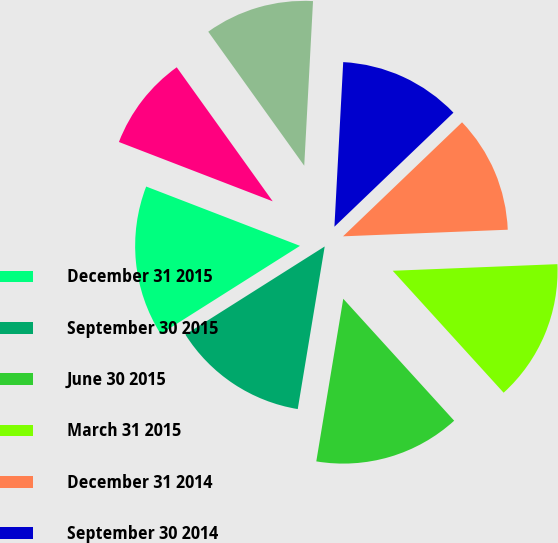Convert chart to OTSL. <chart><loc_0><loc_0><loc_500><loc_500><pie_chart><fcel>December 31 2015<fcel>September 30 2015<fcel>June 30 2015<fcel>March 31 2015<fcel>December 31 2014<fcel>September 30 2014<fcel>June 30 2014<fcel>March 31 2014<nl><fcel>14.83%<fcel>13.41%<fcel>14.36%<fcel>13.89%<fcel>11.52%<fcel>11.99%<fcel>10.74%<fcel>9.25%<nl></chart> 